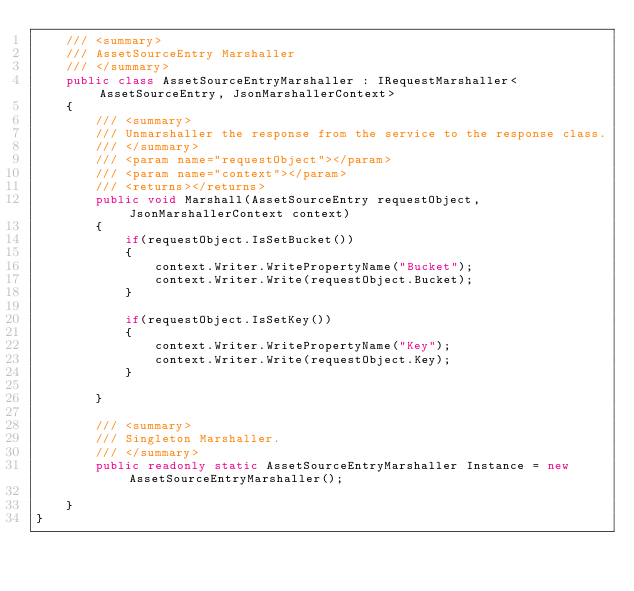<code> <loc_0><loc_0><loc_500><loc_500><_C#_>    /// <summary>
    /// AssetSourceEntry Marshaller
    /// </summary>
    public class AssetSourceEntryMarshaller : IRequestMarshaller<AssetSourceEntry, JsonMarshallerContext> 
    {
        /// <summary>
        /// Unmarshaller the response from the service to the response class.
        /// </summary>  
        /// <param name="requestObject"></param>
        /// <param name="context"></param>
        /// <returns></returns>
        public void Marshall(AssetSourceEntry requestObject, JsonMarshallerContext context)
        {
            if(requestObject.IsSetBucket())
            {
                context.Writer.WritePropertyName("Bucket");
                context.Writer.Write(requestObject.Bucket);
            }

            if(requestObject.IsSetKey())
            {
                context.Writer.WritePropertyName("Key");
                context.Writer.Write(requestObject.Key);
            }

        }

        /// <summary>
        /// Singleton Marshaller.
        /// </summary>
        public readonly static AssetSourceEntryMarshaller Instance = new AssetSourceEntryMarshaller();

    }
}</code> 